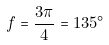Convert formula to latex. <formula><loc_0><loc_0><loc_500><loc_500>f = \frac { 3 \pi } { 4 } = 1 3 5 ^ { \circ }</formula> 